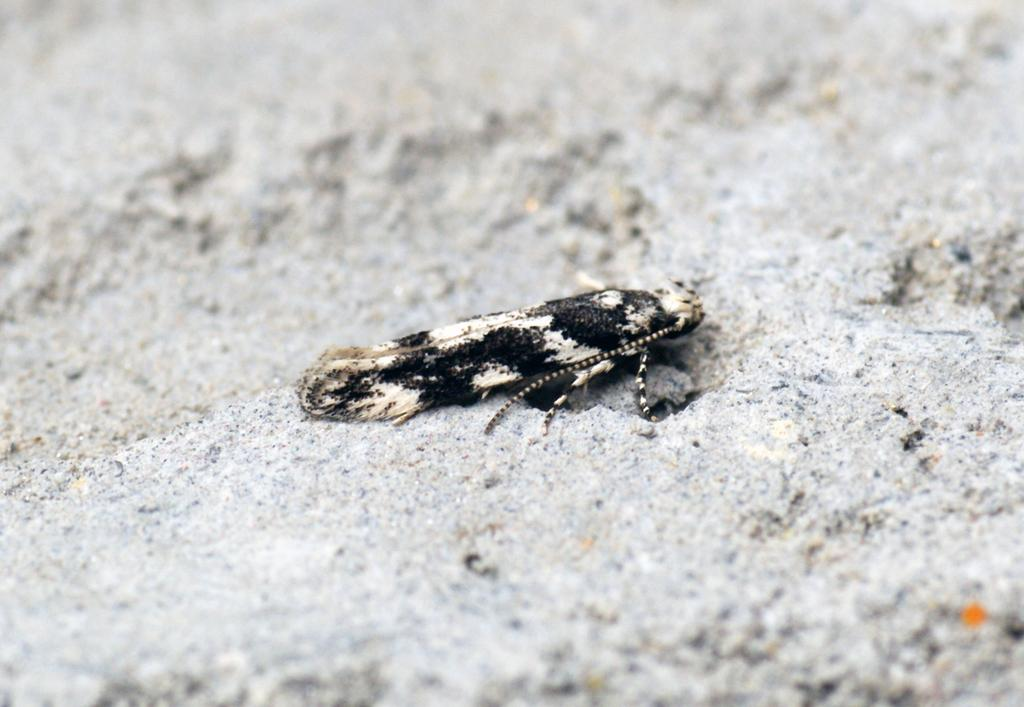What type of creature is present in the image? There is an insect in the image. Where is the insect located in the image? The insect is on the floor. What type of crack is the insect using to travel in the image? There is no crack present in the image, and the insect is not shown traveling. 